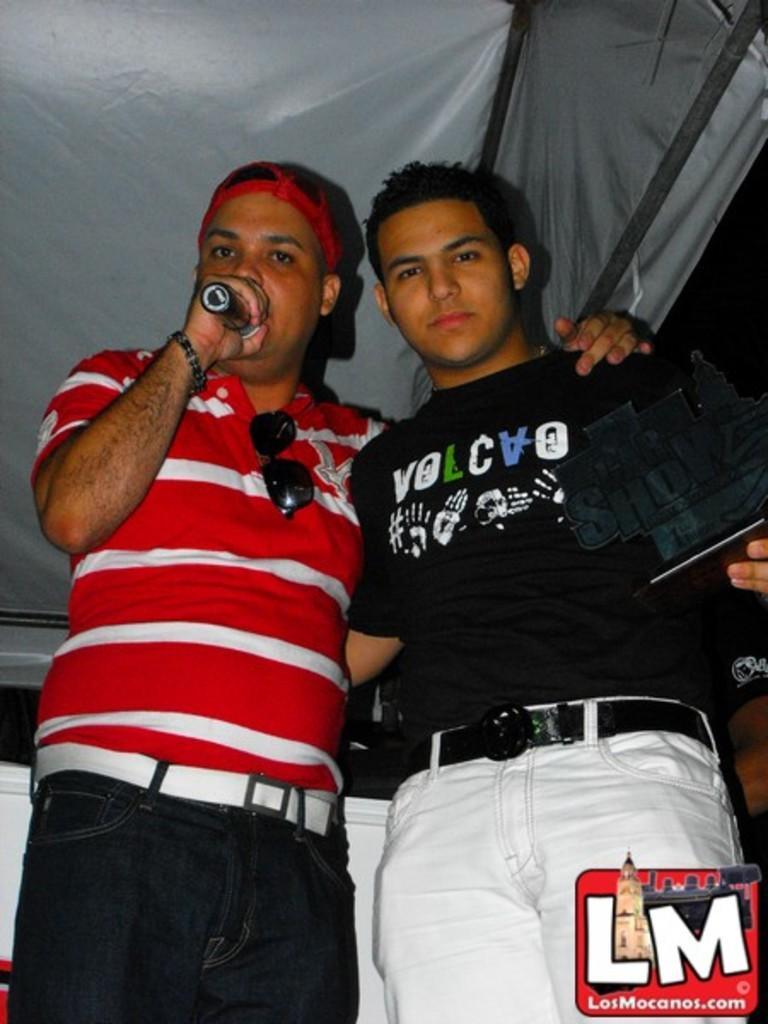Could you give a brief overview of what you see in this image? In the center of the image we can see two men standing on the floor. In the background we can see tent, wall and sky. 